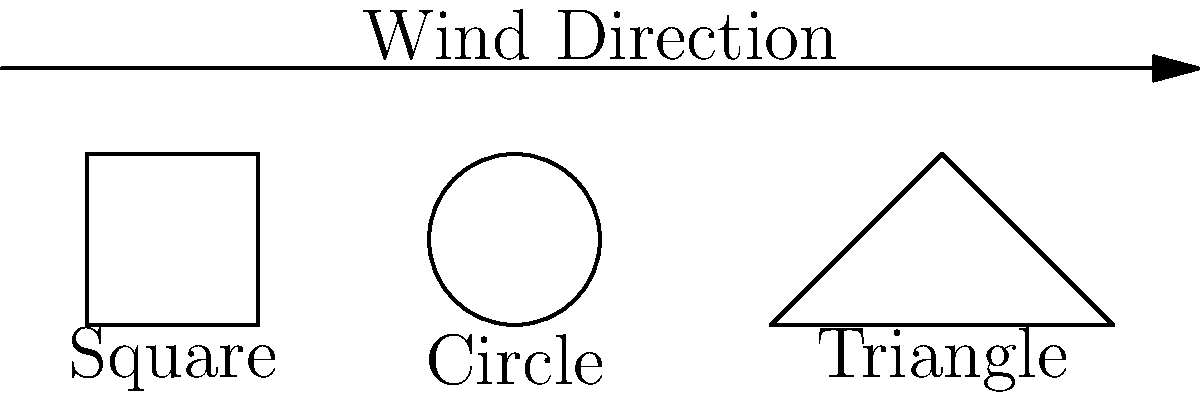A high-rise building is being designed in an area with strong winds. The building's cross-sectional shape can be square, circular, or triangular. Given that the wind speed is 40 m/s, the air density is 1.225 kg/m³, and the drag coefficients for square, circular, and triangular shapes are 2.0, 0.47, and 1.3 respectively, calculate the wind load per unit height (in N/m) for each shape. Which shape would you recommend for minimizing wind load, and why? To calculate the wind load per unit height, we'll use the formula:

$$F = \frac{1}{2} \rho v^2 C_d A$$

Where:
$F$ = Wind load (N)
$\rho$ = Air density (kg/m³)
$v$ = Wind speed (m/s)
$C_d$ = Drag coefficient
$A$ = Area per unit height (m²/m = m)

Given:
$\rho = 1.225$ kg/m³
$v = 40$ m/s

Step 1: Calculate wind load for square shape
$C_d = 2.0$, $A = 1$ m
$$F_{square} = \frac{1}{2} \cdot 1.225 \cdot 40^2 \cdot 2.0 \cdot 1 = 1960 \text{ N/m}$$

Step 2: Calculate wind load for circular shape
$C_d = 0.47$, $A = 1$ m
$$F_{circle} = \frac{1}{2} \cdot 1.225 \cdot 40^2 \cdot 0.47 \cdot 1 = 460.6 \text{ N/m}$$

Step 3: Calculate wind load for triangular shape
$C_d = 1.3$, $A = 1$ m
$$F_{triangle} = \frac{1}{2} \cdot 1.225 \cdot 40^2 \cdot 1.3 \cdot 1 = 1274 \text{ N/m}$$

Step 4: Compare results
The circular shape has the lowest wind load per unit height, followed by the triangular shape, and then the square shape.

Recommendation: Choose the circular shape to minimize wind load. This shape has the lowest drag coefficient, resulting in the least wind resistance and lowest wind load on the building.
Answer: Circular shape; wind loads: Square 1960 N/m, Circle 460.6 N/m, Triangle 1274 N/m. 